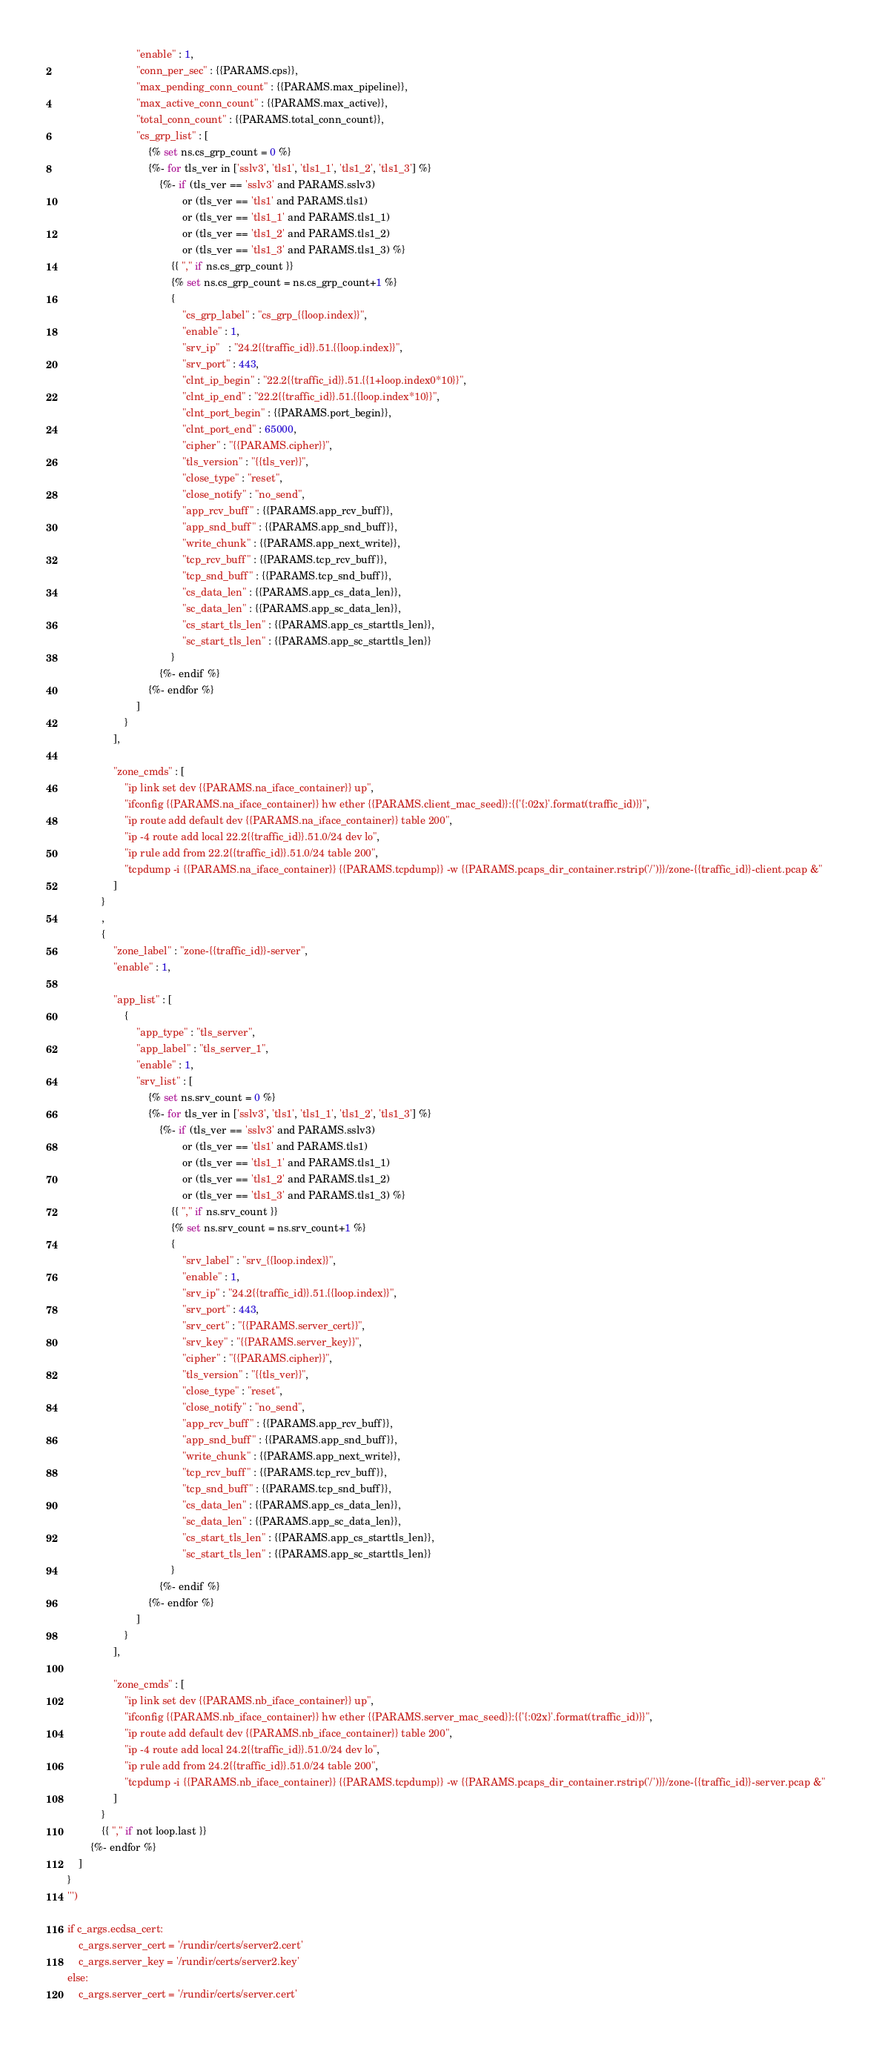Convert code to text. <code><loc_0><loc_0><loc_500><loc_500><_Python_>                            "enable" : 1,
                            "conn_per_sec" : {{PARAMS.cps}},
                            "max_pending_conn_count" : {{PARAMS.max_pipeline}},
                            "max_active_conn_count" : {{PARAMS.max_active}},
                            "total_conn_count" : {{PARAMS.total_conn_count}},
                            "cs_grp_list" : [
                                {% set ns.cs_grp_count = 0 %}
                                {%- for tls_ver in ['sslv3', 'tls1', 'tls1_1', 'tls1_2', 'tls1_3'] %}
                                    {%- if (tls_ver == 'sslv3' and PARAMS.sslv3) 
                                            or (tls_ver == 'tls1' and PARAMS.tls1) 
                                            or (tls_ver == 'tls1_1' and PARAMS.tls1_1) 
                                            or (tls_ver == 'tls1_2' and PARAMS.tls1_2) 
                                            or (tls_ver == 'tls1_3' and PARAMS.tls1_3) %}
                                        {{ "," if ns.cs_grp_count }}
                                        {% set ns.cs_grp_count = ns.cs_grp_count+1 %}
                                        {
                                            "cs_grp_label" : "cs_grp_{{loop.index}}",
                                            "enable" : 1,
                                            "srv_ip"   : "24.2{{traffic_id}}.51.{{loop.index}}",
                                            "srv_port" : 443,
                                            "clnt_ip_begin" : "22.2{{traffic_id}}.51.{{1+loop.index0*10}}",
                                            "clnt_ip_end" : "22.2{{traffic_id}}.51.{{loop.index*10}}",
                                            "clnt_port_begin" : {{PARAMS.port_begin}},
                                            "clnt_port_end" : 65000,
                                            "cipher" : "{{PARAMS.cipher}}",
                                            "tls_version" : "{{tls_ver}}",
                                            "close_type" : "reset",
                                            "close_notify" : "no_send",
                                            "app_rcv_buff" : {{PARAMS.app_rcv_buff}},
                                            "app_snd_buff" : {{PARAMS.app_snd_buff}},
                                            "write_chunk" : {{PARAMS.app_next_write}},
                                            "tcp_rcv_buff" : {{PARAMS.tcp_rcv_buff}},
                                            "tcp_snd_buff" : {{PARAMS.tcp_snd_buff}},
                                            "cs_data_len" : {{PARAMS.app_cs_data_len}},
                                            "sc_data_len" : {{PARAMS.app_sc_data_len}},
                                            "cs_start_tls_len" : {{PARAMS.app_cs_starttls_len}},
                                            "sc_start_tls_len" : {{PARAMS.app_sc_starttls_len}}
                                        }
                                    {%- endif %}
                                {%- endfor %}                         
                            ]
                        }
                    ],

                    "zone_cmds" : [
                        "ip link set dev {{PARAMS.na_iface_container}} up",
                        "ifconfig {{PARAMS.na_iface_container}} hw ether {{PARAMS.client_mac_seed}}:{{'{:02x}'.format(traffic_id)}}",
                        "ip route add default dev {{PARAMS.na_iface_container}} table 200",
                        "ip -4 route add local 22.2{{traffic_id}}.51.0/24 dev lo",
                        "ip rule add from 22.2{{traffic_id}}.51.0/24 table 200",
                        "tcpdump -i {{PARAMS.na_iface_container}} {{PARAMS.tcpdump}} -w {{PARAMS.pcaps_dir_container.rstrip('/')}}/zone-{{traffic_id}}-client.pcap &"
                    ]                    
                }
                ,
                {
                    "zone_label" : "zone-{{traffic_id}}-server",
                    "enable" : 1,

                    "app_list" : [
                        {
                            "app_type" : "tls_server",
                            "app_label" : "tls_server_1",
                            "enable" : 1,
                            "srv_list" : [
                                {% set ns.srv_count = 0 %}
                                {%- for tls_ver in ['sslv3', 'tls1', 'tls1_1', 'tls1_2', 'tls1_3'] %}
                                    {%- if (tls_ver == 'sslv3' and PARAMS.sslv3) 
                                            or (tls_ver == 'tls1' and PARAMS.tls1) 
                                            or (tls_ver == 'tls1_1' and PARAMS.tls1_1) 
                                            or (tls_ver == 'tls1_2' and PARAMS.tls1_2) 
                                            or (tls_ver == 'tls1_3' and PARAMS.tls1_3) %}
                                        {{ "," if ns.srv_count }}
                                        {% set ns.srv_count = ns.srv_count+1 %}
                                        {
                                            "srv_label" : "srv_{{loop.index}}",
                                            "enable" : 1,
                                            "srv_ip" : "24.2{{traffic_id}}.51.{{loop.index}}",
                                            "srv_port" : 443,
                                            "srv_cert" : "{{PARAMS.server_cert}}",
                                            "srv_key" : "{{PARAMS.server_key}}",
                                            "cipher" : "{{PARAMS.cipher}}",
                                            "tls_version" : "{{tls_ver}}",
                                            "close_type" : "reset",
                                            "close_notify" : "no_send",
                                            "app_rcv_buff" : {{PARAMS.app_rcv_buff}},
                                            "app_snd_buff" : {{PARAMS.app_snd_buff}},
                                            "write_chunk" : {{PARAMS.app_next_write}},
                                            "tcp_rcv_buff" : {{PARAMS.tcp_rcv_buff}},
                                            "tcp_snd_buff" : {{PARAMS.tcp_snd_buff}},
                                            "cs_data_len" : {{PARAMS.app_cs_data_len}},
                                            "sc_data_len" : {{PARAMS.app_sc_data_len}},
                                            "cs_start_tls_len" : {{PARAMS.app_cs_starttls_len}},
                                            "sc_start_tls_len" : {{PARAMS.app_sc_starttls_len}}
                                        }
                                    {%- endif %}
                                {%- endfor %}
                            ]
                        }
                    ],

                    "zone_cmds" : [
                        "ip link set dev {{PARAMS.nb_iface_container}} up",
                        "ifconfig {{PARAMS.nb_iface_container}} hw ether {{PARAMS.server_mac_seed}}:{{'{:02x}'.format(traffic_id)}}",
                        "ip route add default dev {{PARAMS.nb_iface_container}} table 200",
                        "ip -4 route add local 24.2{{traffic_id}}.51.0/24 dev lo",
                        "ip rule add from 24.2{{traffic_id}}.51.0/24 table 200",
                        "tcpdump -i {{PARAMS.nb_iface_container}} {{PARAMS.tcpdump}} -w {{PARAMS.pcaps_dir_container.rstrip('/')}}/zone-{{traffic_id}}-server.pcap &"
                    ]
                }
                {{ "," if not loop.last }}
            {%- endfor %}
        ]
    }
    ''')

    if c_args.ecdsa_cert:
        c_args.server_cert = '/rundir/certs/server2.cert'
        c_args.server_key = '/rundir/certs/server2.key'
    else:
        c_args.server_cert = '/rundir/certs/server.cert'</code> 